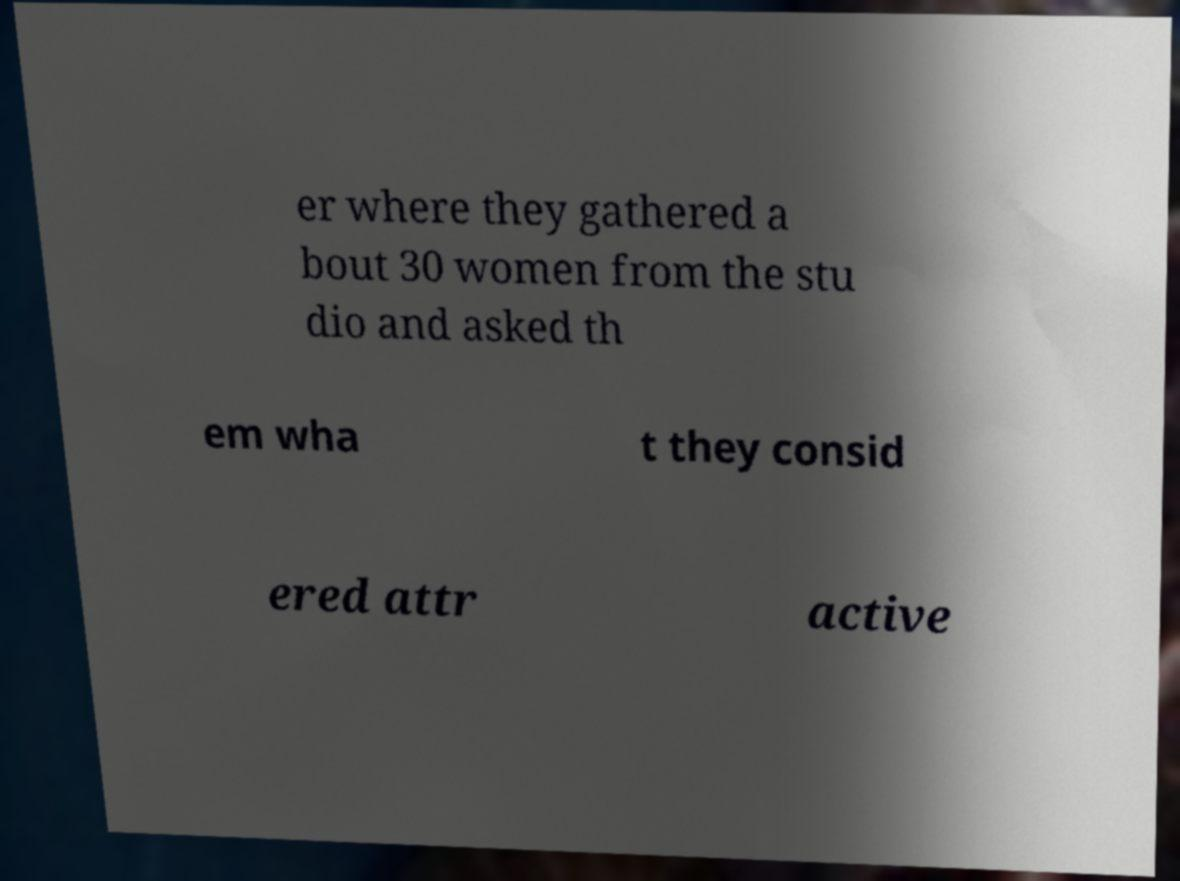Could you assist in decoding the text presented in this image and type it out clearly? er where they gathered a bout 30 women from the stu dio and asked th em wha t they consid ered attr active 